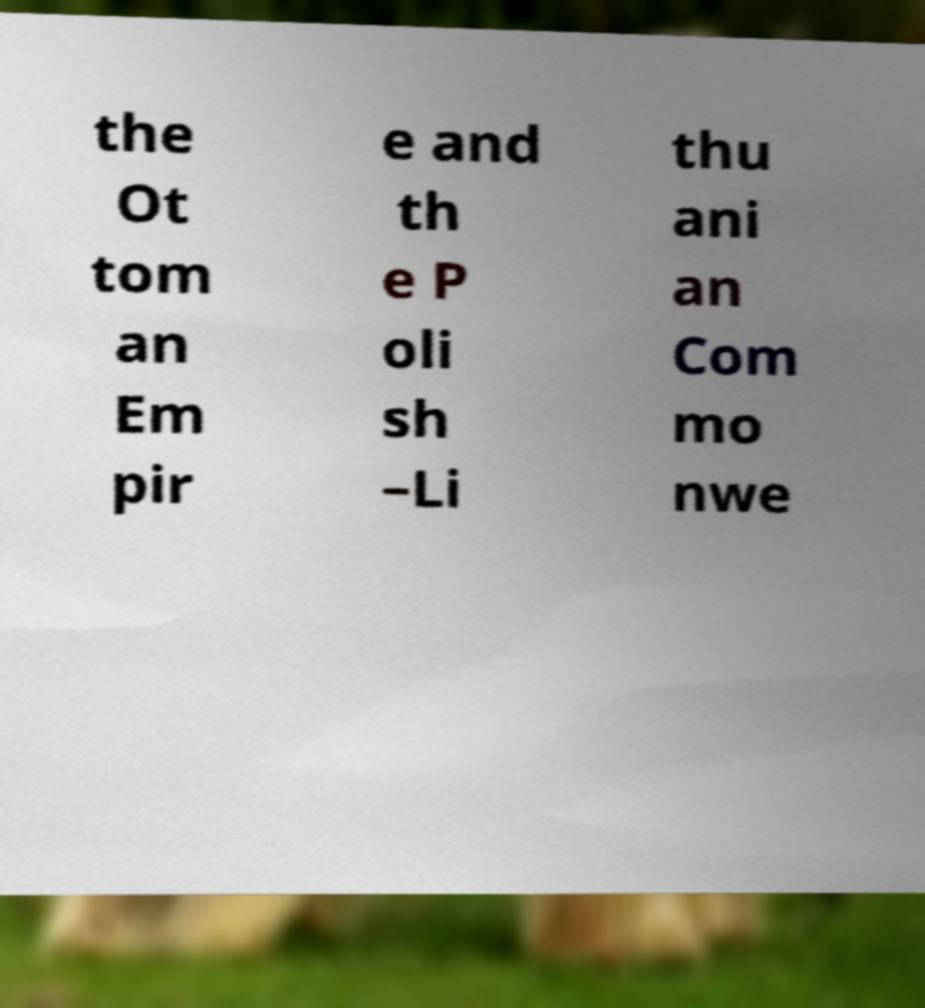Can you read and provide the text displayed in the image?This photo seems to have some interesting text. Can you extract and type it out for me? the Ot tom an Em pir e and th e P oli sh –Li thu ani an Com mo nwe 